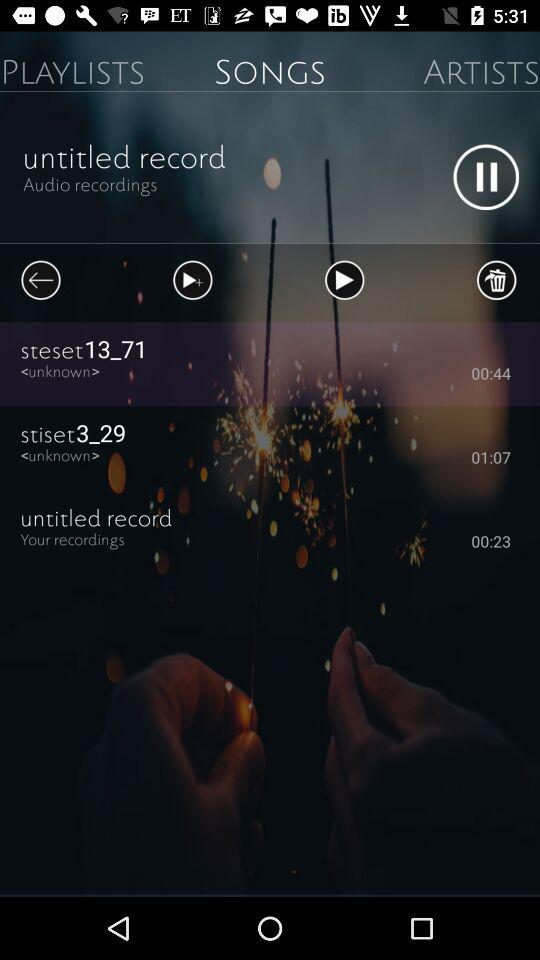Which song is currently playing? The currently playing song is "untitled record". 